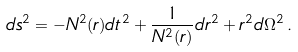Convert formula to latex. <formula><loc_0><loc_0><loc_500><loc_500>d s ^ { 2 } = - N ^ { 2 } ( r ) d t ^ { 2 } + \frac { 1 } { N ^ { 2 } ( r ) } d r ^ { 2 } + r ^ { 2 } d \Omega ^ { 2 } \, .</formula> 